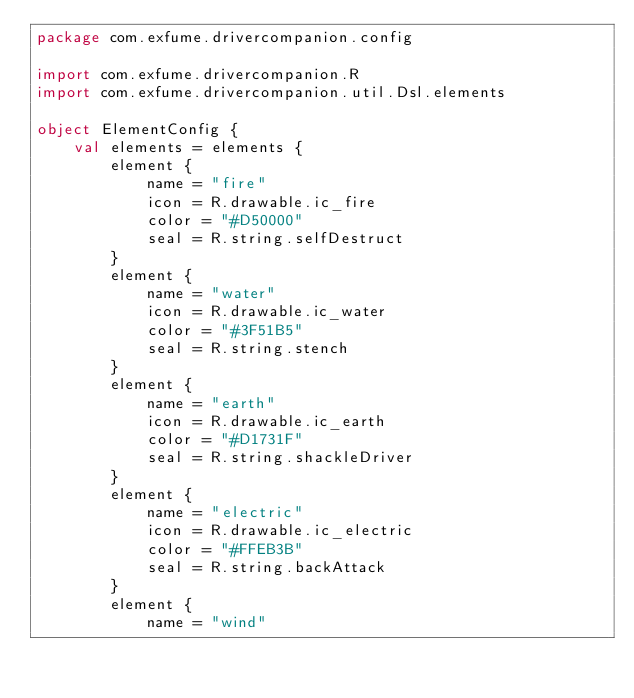Convert code to text. <code><loc_0><loc_0><loc_500><loc_500><_Kotlin_>package com.exfume.drivercompanion.config

import com.exfume.drivercompanion.R
import com.exfume.drivercompanion.util.Dsl.elements

object ElementConfig {
    val elements = elements {
        element {
            name = "fire"
            icon = R.drawable.ic_fire
            color = "#D50000"
            seal = R.string.selfDestruct
        }
        element {
            name = "water"
            icon = R.drawable.ic_water
            color = "#3F51B5"
            seal = R.string.stench
        }
        element {
            name = "earth"
            icon = R.drawable.ic_earth
            color = "#D1731F"
            seal = R.string.shackleDriver
        }
        element {
            name = "electric"
            icon = R.drawable.ic_electric
            color = "#FFEB3B"
            seal = R.string.backAttack
        }
        element {
            name = "wind"</code> 